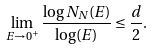Convert formula to latex. <formula><loc_0><loc_0><loc_500><loc_500>\lim _ { E \to 0 ^ { + } } \frac { \log N _ { N } ( E ) } { \log ( E ) } \leq \frac { d } { 2 } .</formula> 